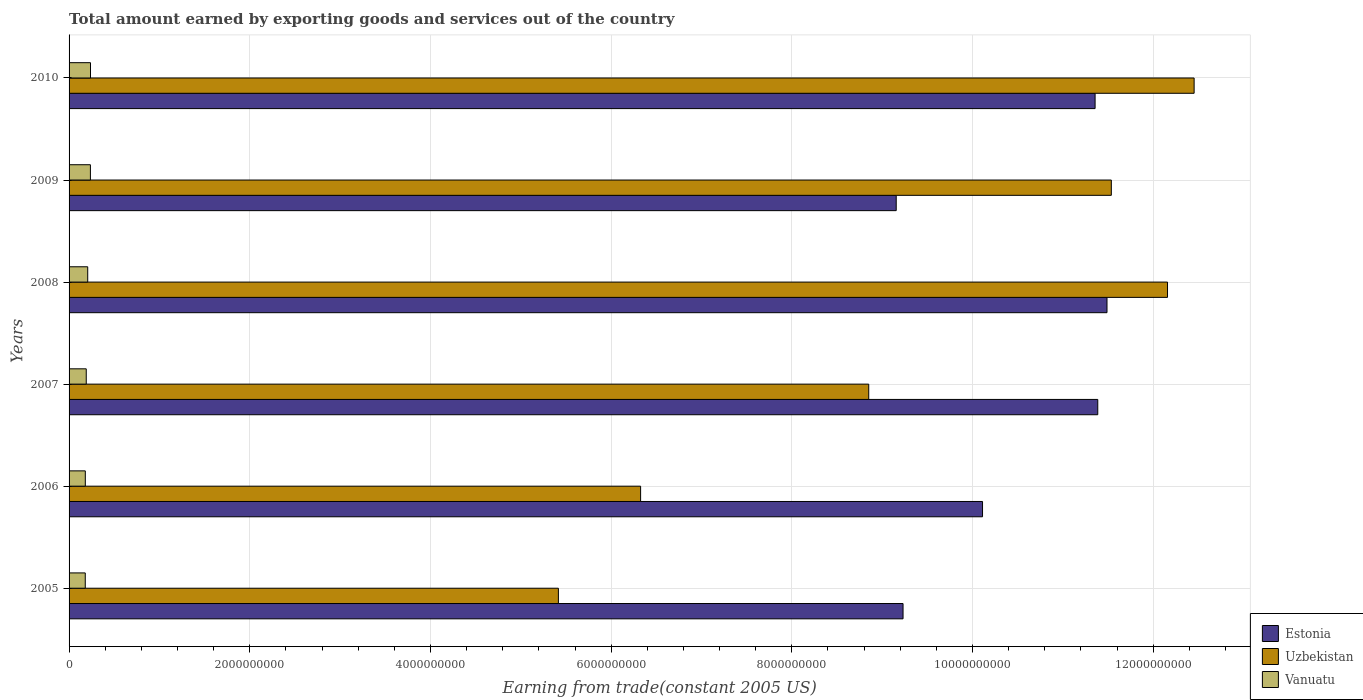How many different coloured bars are there?
Offer a very short reply. 3. How many bars are there on the 3rd tick from the top?
Your answer should be very brief. 3. In how many cases, is the number of bars for a given year not equal to the number of legend labels?
Give a very brief answer. 0. What is the total amount earned by exporting goods and services in Uzbekistan in 2006?
Keep it short and to the point. 6.33e+09. Across all years, what is the maximum total amount earned by exporting goods and services in Uzbekistan?
Provide a short and direct response. 1.25e+1. Across all years, what is the minimum total amount earned by exporting goods and services in Vanuatu?
Make the answer very short. 1.79e+08. In which year was the total amount earned by exporting goods and services in Estonia minimum?
Give a very brief answer. 2009. What is the total total amount earned by exporting goods and services in Estonia in the graph?
Keep it short and to the point. 6.27e+1. What is the difference between the total amount earned by exporting goods and services in Estonia in 2006 and that in 2009?
Make the answer very short. 9.55e+08. What is the difference between the total amount earned by exporting goods and services in Estonia in 2006 and the total amount earned by exporting goods and services in Uzbekistan in 2005?
Make the answer very short. 4.69e+09. What is the average total amount earned by exporting goods and services in Uzbekistan per year?
Ensure brevity in your answer.  9.46e+09. In the year 2009, what is the difference between the total amount earned by exporting goods and services in Estonia and total amount earned by exporting goods and services in Uzbekistan?
Your answer should be very brief. -2.38e+09. In how many years, is the total amount earned by exporting goods and services in Uzbekistan greater than 10000000000 US$?
Your answer should be compact. 3. What is the ratio of the total amount earned by exporting goods and services in Uzbekistan in 2006 to that in 2010?
Offer a terse response. 0.51. What is the difference between the highest and the second highest total amount earned by exporting goods and services in Estonia?
Provide a succinct answer. 1.02e+08. What is the difference between the highest and the lowest total amount earned by exporting goods and services in Uzbekistan?
Your answer should be compact. 7.04e+09. In how many years, is the total amount earned by exporting goods and services in Uzbekistan greater than the average total amount earned by exporting goods and services in Uzbekistan taken over all years?
Provide a succinct answer. 3. What does the 2nd bar from the top in 2009 represents?
Keep it short and to the point. Uzbekistan. What does the 3rd bar from the bottom in 2009 represents?
Make the answer very short. Vanuatu. Is it the case that in every year, the sum of the total amount earned by exporting goods and services in Vanuatu and total amount earned by exporting goods and services in Uzbekistan is greater than the total amount earned by exporting goods and services in Estonia?
Make the answer very short. No. How many bars are there?
Your response must be concise. 18. How many years are there in the graph?
Offer a very short reply. 6. Are the values on the major ticks of X-axis written in scientific E-notation?
Provide a short and direct response. No. Does the graph contain any zero values?
Make the answer very short. No. Where does the legend appear in the graph?
Your answer should be very brief. Bottom right. How many legend labels are there?
Provide a short and direct response. 3. How are the legend labels stacked?
Offer a terse response. Vertical. What is the title of the graph?
Give a very brief answer. Total amount earned by exporting goods and services out of the country. What is the label or title of the X-axis?
Your answer should be compact. Earning from trade(constant 2005 US). What is the label or title of the Y-axis?
Ensure brevity in your answer.  Years. What is the Earning from trade(constant 2005 US) of Estonia in 2005?
Offer a terse response. 9.23e+09. What is the Earning from trade(constant 2005 US) of Uzbekistan in 2005?
Your response must be concise. 5.42e+09. What is the Earning from trade(constant 2005 US) in Vanuatu in 2005?
Your response must be concise. 1.79e+08. What is the Earning from trade(constant 2005 US) of Estonia in 2006?
Make the answer very short. 1.01e+1. What is the Earning from trade(constant 2005 US) of Uzbekistan in 2006?
Keep it short and to the point. 6.33e+09. What is the Earning from trade(constant 2005 US) of Vanuatu in 2006?
Keep it short and to the point. 1.80e+08. What is the Earning from trade(constant 2005 US) of Estonia in 2007?
Make the answer very short. 1.14e+1. What is the Earning from trade(constant 2005 US) in Uzbekistan in 2007?
Keep it short and to the point. 8.85e+09. What is the Earning from trade(constant 2005 US) in Vanuatu in 2007?
Your response must be concise. 1.90e+08. What is the Earning from trade(constant 2005 US) in Estonia in 2008?
Your answer should be compact. 1.15e+1. What is the Earning from trade(constant 2005 US) of Uzbekistan in 2008?
Ensure brevity in your answer.  1.22e+1. What is the Earning from trade(constant 2005 US) of Vanuatu in 2008?
Keep it short and to the point. 2.06e+08. What is the Earning from trade(constant 2005 US) in Estonia in 2009?
Offer a terse response. 9.16e+09. What is the Earning from trade(constant 2005 US) of Uzbekistan in 2009?
Give a very brief answer. 1.15e+1. What is the Earning from trade(constant 2005 US) of Vanuatu in 2009?
Provide a short and direct response. 2.36e+08. What is the Earning from trade(constant 2005 US) in Estonia in 2010?
Your answer should be compact. 1.14e+1. What is the Earning from trade(constant 2005 US) in Uzbekistan in 2010?
Keep it short and to the point. 1.25e+1. What is the Earning from trade(constant 2005 US) in Vanuatu in 2010?
Offer a terse response. 2.37e+08. Across all years, what is the maximum Earning from trade(constant 2005 US) of Estonia?
Your response must be concise. 1.15e+1. Across all years, what is the maximum Earning from trade(constant 2005 US) in Uzbekistan?
Offer a very short reply. 1.25e+1. Across all years, what is the maximum Earning from trade(constant 2005 US) in Vanuatu?
Your response must be concise. 2.37e+08. Across all years, what is the minimum Earning from trade(constant 2005 US) of Estonia?
Your answer should be very brief. 9.16e+09. Across all years, what is the minimum Earning from trade(constant 2005 US) of Uzbekistan?
Make the answer very short. 5.42e+09. Across all years, what is the minimum Earning from trade(constant 2005 US) of Vanuatu?
Your answer should be very brief. 1.79e+08. What is the total Earning from trade(constant 2005 US) in Estonia in the graph?
Keep it short and to the point. 6.27e+1. What is the total Earning from trade(constant 2005 US) in Uzbekistan in the graph?
Provide a succinct answer. 5.67e+1. What is the total Earning from trade(constant 2005 US) in Vanuatu in the graph?
Make the answer very short. 1.23e+09. What is the difference between the Earning from trade(constant 2005 US) in Estonia in 2005 and that in 2006?
Provide a succinct answer. -8.80e+08. What is the difference between the Earning from trade(constant 2005 US) in Uzbekistan in 2005 and that in 2006?
Provide a short and direct response. -9.10e+08. What is the difference between the Earning from trade(constant 2005 US) of Vanuatu in 2005 and that in 2006?
Provide a short and direct response. -4.48e+05. What is the difference between the Earning from trade(constant 2005 US) in Estonia in 2005 and that in 2007?
Keep it short and to the point. -2.16e+09. What is the difference between the Earning from trade(constant 2005 US) in Uzbekistan in 2005 and that in 2007?
Provide a short and direct response. -3.44e+09. What is the difference between the Earning from trade(constant 2005 US) of Vanuatu in 2005 and that in 2007?
Provide a short and direct response. -1.09e+07. What is the difference between the Earning from trade(constant 2005 US) of Estonia in 2005 and that in 2008?
Your answer should be very brief. -2.26e+09. What is the difference between the Earning from trade(constant 2005 US) of Uzbekistan in 2005 and that in 2008?
Keep it short and to the point. -6.74e+09. What is the difference between the Earning from trade(constant 2005 US) of Vanuatu in 2005 and that in 2008?
Offer a very short reply. -2.72e+07. What is the difference between the Earning from trade(constant 2005 US) of Estonia in 2005 and that in 2009?
Your answer should be very brief. 7.57e+07. What is the difference between the Earning from trade(constant 2005 US) in Uzbekistan in 2005 and that in 2009?
Offer a very short reply. -6.12e+09. What is the difference between the Earning from trade(constant 2005 US) in Vanuatu in 2005 and that in 2009?
Ensure brevity in your answer.  -5.70e+07. What is the difference between the Earning from trade(constant 2005 US) of Estonia in 2005 and that in 2010?
Your answer should be very brief. -2.13e+09. What is the difference between the Earning from trade(constant 2005 US) of Uzbekistan in 2005 and that in 2010?
Give a very brief answer. -7.04e+09. What is the difference between the Earning from trade(constant 2005 US) of Vanuatu in 2005 and that in 2010?
Make the answer very short. -5.80e+07. What is the difference between the Earning from trade(constant 2005 US) of Estonia in 2006 and that in 2007?
Provide a short and direct response. -1.28e+09. What is the difference between the Earning from trade(constant 2005 US) of Uzbekistan in 2006 and that in 2007?
Your response must be concise. -2.52e+09. What is the difference between the Earning from trade(constant 2005 US) of Vanuatu in 2006 and that in 2007?
Give a very brief answer. -1.04e+07. What is the difference between the Earning from trade(constant 2005 US) in Estonia in 2006 and that in 2008?
Your response must be concise. -1.38e+09. What is the difference between the Earning from trade(constant 2005 US) of Uzbekistan in 2006 and that in 2008?
Ensure brevity in your answer.  -5.83e+09. What is the difference between the Earning from trade(constant 2005 US) in Vanuatu in 2006 and that in 2008?
Ensure brevity in your answer.  -2.68e+07. What is the difference between the Earning from trade(constant 2005 US) of Estonia in 2006 and that in 2009?
Your answer should be compact. 9.55e+08. What is the difference between the Earning from trade(constant 2005 US) in Uzbekistan in 2006 and that in 2009?
Provide a short and direct response. -5.21e+09. What is the difference between the Earning from trade(constant 2005 US) in Vanuatu in 2006 and that in 2009?
Your answer should be compact. -5.65e+07. What is the difference between the Earning from trade(constant 2005 US) in Estonia in 2006 and that in 2010?
Provide a succinct answer. -1.25e+09. What is the difference between the Earning from trade(constant 2005 US) in Uzbekistan in 2006 and that in 2010?
Make the answer very short. -6.13e+09. What is the difference between the Earning from trade(constant 2005 US) in Vanuatu in 2006 and that in 2010?
Offer a very short reply. -5.75e+07. What is the difference between the Earning from trade(constant 2005 US) of Estonia in 2007 and that in 2008?
Offer a very short reply. -1.02e+08. What is the difference between the Earning from trade(constant 2005 US) in Uzbekistan in 2007 and that in 2008?
Your response must be concise. -3.31e+09. What is the difference between the Earning from trade(constant 2005 US) of Vanuatu in 2007 and that in 2008?
Provide a succinct answer. -1.64e+07. What is the difference between the Earning from trade(constant 2005 US) of Estonia in 2007 and that in 2009?
Offer a terse response. 2.23e+09. What is the difference between the Earning from trade(constant 2005 US) in Uzbekistan in 2007 and that in 2009?
Ensure brevity in your answer.  -2.69e+09. What is the difference between the Earning from trade(constant 2005 US) in Vanuatu in 2007 and that in 2009?
Offer a terse response. -4.61e+07. What is the difference between the Earning from trade(constant 2005 US) of Estonia in 2007 and that in 2010?
Offer a very short reply. 2.95e+07. What is the difference between the Earning from trade(constant 2005 US) of Uzbekistan in 2007 and that in 2010?
Your response must be concise. -3.60e+09. What is the difference between the Earning from trade(constant 2005 US) in Vanuatu in 2007 and that in 2010?
Keep it short and to the point. -4.71e+07. What is the difference between the Earning from trade(constant 2005 US) in Estonia in 2008 and that in 2009?
Make the answer very short. 2.33e+09. What is the difference between the Earning from trade(constant 2005 US) of Uzbekistan in 2008 and that in 2009?
Offer a very short reply. 6.22e+08. What is the difference between the Earning from trade(constant 2005 US) of Vanuatu in 2008 and that in 2009?
Give a very brief answer. -2.98e+07. What is the difference between the Earning from trade(constant 2005 US) of Estonia in 2008 and that in 2010?
Make the answer very short. 1.32e+08. What is the difference between the Earning from trade(constant 2005 US) in Uzbekistan in 2008 and that in 2010?
Your response must be concise. -2.95e+08. What is the difference between the Earning from trade(constant 2005 US) in Vanuatu in 2008 and that in 2010?
Your answer should be compact. -3.07e+07. What is the difference between the Earning from trade(constant 2005 US) in Estonia in 2009 and that in 2010?
Provide a succinct answer. -2.20e+09. What is the difference between the Earning from trade(constant 2005 US) of Uzbekistan in 2009 and that in 2010?
Offer a terse response. -9.17e+08. What is the difference between the Earning from trade(constant 2005 US) in Vanuatu in 2009 and that in 2010?
Your answer should be compact. -9.76e+05. What is the difference between the Earning from trade(constant 2005 US) of Estonia in 2005 and the Earning from trade(constant 2005 US) of Uzbekistan in 2006?
Provide a succinct answer. 2.90e+09. What is the difference between the Earning from trade(constant 2005 US) in Estonia in 2005 and the Earning from trade(constant 2005 US) in Vanuatu in 2006?
Ensure brevity in your answer.  9.05e+09. What is the difference between the Earning from trade(constant 2005 US) in Uzbekistan in 2005 and the Earning from trade(constant 2005 US) in Vanuatu in 2006?
Your answer should be compact. 5.24e+09. What is the difference between the Earning from trade(constant 2005 US) of Estonia in 2005 and the Earning from trade(constant 2005 US) of Uzbekistan in 2007?
Give a very brief answer. 3.80e+08. What is the difference between the Earning from trade(constant 2005 US) in Estonia in 2005 and the Earning from trade(constant 2005 US) in Vanuatu in 2007?
Ensure brevity in your answer.  9.04e+09. What is the difference between the Earning from trade(constant 2005 US) of Uzbekistan in 2005 and the Earning from trade(constant 2005 US) of Vanuatu in 2007?
Your answer should be very brief. 5.23e+09. What is the difference between the Earning from trade(constant 2005 US) in Estonia in 2005 and the Earning from trade(constant 2005 US) in Uzbekistan in 2008?
Offer a very short reply. -2.93e+09. What is the difference between the Earning from trade(constant 2005 US) in Estonia in 2005 and the Earning from trade(constant 2005 US) in Vanuatu in 2008?
Offer a terse response. 9.02e+09. What is the difference between the Earning from trade(constant 2005 US) in Uzbekistan in 2005 and the Earning from trade(constant 2005 US) in Vanuatu in 2008?
Your response must be concise. 5.21e+09. What is the difference between the Earning from trade(constant 2005 US) of Estonia in 2005 and the Earning from trade(constant 2005 US) of Uzbekistan in 2009?
Your answer should be compact. -2.31e+09. What is the difference between the Earning from trade(constant 2005 US) of Estonia in 2005 and the Earning from trade(constant 2005 US) of Vanuatu in 2009?
Provide a succinct answer. 8.99e+09. What is the difference between the Earning from trade(constant 2005 US) in Uzbekistan in 2005 and the Earning from trade(constant 2005 US) in Vanuatu in 2009?
Offer a very short reply. 5.18e+09. What is the difference between the Earning from trade(constant 2005 US) of Estonia in 2005 and the Earning from trade(constant 2005 US) of Uzbekistan in 2010?
Provide a short and direct response. -3.22e+09. What is the difference between the Earning from trade(constant 2005 US) in Estonia in 2005 and the Earning from trade(constant 2005 US) in Vanuatu in 2010?
Give a very brief answer. 8.99e+09. What is the difference between the Earning from trade(constant 2005 US) in Uzbekistan in 2005 and the Earning from trade(constant 2005 US) in Vanuatu in 2010?
Your response must be concise. 5.18e+09. What is the difference between the Earning from trade(constant 2005 US) of Estonia in 2006 and the Earning from trade(constant 2005 US) of Uzbekistan in 2007?
Offer a terse response. 1.26e+09. What is the difference between the Earning from trade(constant 2005 US) of Estonia in 2006 and the Earning from trade(constant 2005 US) of Vanuatu in 2007?
Give a very brief answer. 9.92e+09. What is the difference between the Earning from trade(constant 2005 US) of Uzbekistan in 2006 and the Earning from trade(constant 2005 US) of Vanuatu in 2007?
Offer a terse response. 6.14e+09. What is the difference between the Earning from trade(constant 2005 US) in Estonia in 2006 and the Earning from trade(constant 2005 US) in Uzbekistan in 2008?
Make the answer very short. -2.05e+09. What is the difference between the Earning from trade(constant 2005 US) in Estonia in 2006 and the Earning from trade(constant 2005 US) in Vanuatu in 2008?
Make the answer very short. 9.90e+09. What is the difference between the Earning from trade(constant 2005 US) of Uzbekistan in 2006 and the Earning from trade(constant 2005 US) of Vanuatu in 2008?
Offer a very short reply. 6.12e+09. What is the difference between the Earning from trade(constant 2005 US) of Estonia in 2006 and the Earning from trade(constant 2005 US) of Uzbekistan in 2009?
Offer a terse response. -1.43e+09. What is the difference between the Earning from trade(constant 2005 US) in Estonia in 2006 and the Earning from trade(constant 2005 US) in Vanuatu in 2009?
Provide a succinct answer. 9.87e+09. What is the difference between the Earning from trade(constant 2005 US) in Uzbekistan in 2006 and the Earning from trade(constant 2005 US) in Vanuatu in 2009?
Provide a succinct answer. 6.09e+09. What is the difference between the Earning from trade(constant 2005 US) in Estonia in 2006 and the Earning from trade(constant 2005 US) in Uzbekistan in 2010?
Your response must be concise. -2.34e+09. What is the difference between the Earning from trade(constant 2005 US) of Estonia in 2006 and the Earning from trade(constant 2005 US) of Vanuatu in 2010?
Make the answer very short. 9.87e+09. What is the difference between the Earning from trade(constant 2005 US) of Uzbekistan in 2006 and the Earning from trade(constant 2005 US) of Vanuatu in 2010?
Your answer should be compact. 6.09e+09. What is the difference between the Earning from trade(constant 2005 US) in Estonia in 2007 and the Earning from trade(constant 2005 US) in Uzbekistan in 2008?
Give a very brief answer. -7.72e+08. What is the difference between the Earning from trade(constant 2005 US) of Estonia in 2007 and the Earning from trade(constant 2005 US) of Vanuatu in 2008?
Your answer should be compact. 1.12e+1. What is the difference between the Earning from trade(constant 2005 US) of Uzbekistan in 2007 and the Earning from trade(constant 2005 US) of Vanuatu in 2008?
Your answer should be compact. 8.64e+09. What is the difference between the Earning from trade(constant 2005 US) in Estonia in 2007 and the Earning from trade(constant 2005 US) in Uzbekistan in 2009?
Your answer should be compact. -1.50e+08. What is the difference between the Earning from trade(constant 2005 US) in Estonia in 2007 and the Earning from trade(constant 2005 US) in Vanuatu in 2009?
Make the answer very short. 1.11e+1. What is the difference between the Earning from trade(constant 2005 US) in Uzbekistan in 2007 and the Earning from trade(constant 2005 US) in Vanuatu in 2009?
Your answer should be compact. 8.61e+09. What is the difference between the Earning from trade(constant 2005 US) of Estonia in 2007 and the Earning from trade(constant 2005 US) of Uzbekistan in 2010?
Your answer should be compact. -1.07e+09. What is the difference between the Earning from trade(constant 2005 US) in Estonia in 2007 and the Earning from trade(constant 2005 US) in Vanuatu in 2010?
Your response must be concise. 1.11e+1. What is the difference between the Earning from trade(constant 2005 US) in Uzbekistan in 2007 and the Earning from trade(constant 2005 US) in Vanuatu in 2010?
Provide a short and direct response. 8.61e+09. What is the difference between the Earning from trade(constant 2005 US) of Estonia in 2008 and the Earning from trade(constant 2005 US) of Uzbekistan in 2009?
Offer a terse response. -4.79e+07. What is the difference between the Earning from trade(constant 2005 US) of Estonia in 2008 and the Earning from trade(constant 2005 US) of Vanuatu in 2009?
Ensure brevity in your answer.  1.13e+1. What is the difference between the Earning from trade(constant 2005 US) in Uzbekistan in 2008 and the Earning from trade(constant 2005 US) in Vanuatu in 2009?
Make the answer very short. 1.19e+1. What is the difference between the Earning from trade(constant 2005 US) of Estonia in 2008 and the Earning from trade(constant 2005 US) of Uzbekistan in 2010?
Offer a very short reply. -9.64e+08. What is the difference between the Earning from trade(constant 2005 US) in Estonia in 2008 and the Earning from trade(constant 2005 US) in Vanuatu in 2010?
Provide a succinct answer. 1.13e+1. What is the difference between the Earning from trade(constant 2005 US) in Uzbekistan in 2008 and the Earning from trade(constant 2005 US) in Vanuatu in 2010?
Provide a short and direct response. 1.19e+1. What is the difference between the Earning from trade(constant 2005 US) of Estonia in 2009 and the Earning from trade(constant 2005 US) of Uzbekistan in 2010?
Provide a succinct answer. -3.30e+09. What is the difference between the Earning from trade(constant 2005 US) in Estonia in 2009 and the Earning from trade(constant 2005 US) in Vanuatu in 2010?
Keep it short and to the point. 8.92e+09. What is the difference between the Earning from trade(constant 2005 US) of Uzbekistan in 2009 and the Earning from trade(constant 2005 US) of Vanuatu in 2010?
Your answer should be very brief. 1.13e+1. What is the average Earning from trade(constant 2005 US) of Estonia per year?
Offer a terse response. 1.05e+1. What is the average Earning from trade(constant 2005 US) of Uzbekistan per year?
Provide a short and direct response. 9.46e+09. What is the average Earning from trade(constant 2005 US) in Vanuatu per year?
Ensure brevity in your answer.  2.05e+08. In the year 2005, what is the difference between the Earning from trade(constant 2005 US) in Estonia and Earning from trade(constant 2005 US) in Uzbekistan?
Provide a succinct answer. 3.81e+09. In the year 2005, what is the difference between the Earning from trade(constant 2005 US) in Estonia and Earning from trade(constant 2005 US) in Vanuatu?
Keep it short and to the point. 9.05e+09. In the year 2005, what is the difference between the Earning from trade(constant 2005 US) of Uzbekistan and Earning from trade(constant 2005 US) of Vanuatu?
Give a very brief answer. 5.24e+09. In the year 2006, what is the difference between the Earning from trade(constant 2005 US) of Estonia and Earning from trade(constant 2005 US) of Uzbekistan?
Provide a succinct answer. 3.78e+09. In the year 2006, what is the difference between the Earning from trade(constant 2005 US) of Estonia and Earning from trade(constant 2005 US) of Vanuatu?
Your response must be concise. 9.93e+09. In the year 2006, what is the difference between the Earning from trade(constant 2005 US) of Uzbekistan and Earning from trade(constant 2005 US) of Vanuatu?
Offer a terse response. 6.15e+09. In the year 2007, what is the difference between the Earning from trade(constant 2005 US) in Estonia and Earning from trade(constant 2005 US) in Uzbekistan?
Make the answer very short. 2.53e+09. In the year 2007, what is the difference between the Earning from trade(constant 2005 US) of Estonia and Earning from trade(constant 2005 US) of Vanuatu?
Your response must be concise. 1.12e+1. In the year 2007, what is the difference between the Earning from trade(constant 2005 US) of Uzbekistan and Earning from trade(constant 2005 US) of Vanuatu?
Your answer should be compact. 8.66e+09. In the year 2008, what is the difference between the Earning from trade(constant 2005 US) of Estonia and Earning from trade(constant 2005 US) of Uzbekistan?
Give a very brief answer. -6.70e+08. In the year 2008, what is the difference between the Earning from trade(constant 2005 US) in Estonia and Earning from trade(constant 2005 US) in Vanuatu?
Make the answer very short. 1.13e+1. In the year 2008, what is the difference between the Earning from trade(constant 2005 US) of Uzbekistan and Earning from trade(constant 2005 US) of Vanuatu?
Your answer should be very brief. 1.20e+1. In the year 2009, what is the difference between the Earning from trade(constant 2005 US) in Estonia and Earning from trade(constant 2005 US) in Uzbekistan?
Give a very brief answer. -2.38e+09. In the year 2009, what is the difference between the Earning from trade(constant 2005 US) in Estonia and Earning from trade(constant 2005 US) in Vanuatu?
Your answer should be very brief. 8.92e+09. In the year 2009, what is the difference between the Earning from trade(constant 2005 US) of Uzbekistan and Earning from trade(constant 2005 US) of Vanuatu?
Offer a terse response. 1.13e+1. In the year 2010, what is the difference between the Earning from trade(constant 2005 US) of Estonia and Earning from trade(constant 2005 US) of Uzbekistan?
Make the answer very short. -1.10e+09. In the year 2010, what is the difference between the Earning from trade(constant 2005 US) in Estonia and Earning from trade(constant 2005 US) in Vanuatu?
Your answer should be very brief. 1.11e+1. In the year 2010, what is the difference between the Earning from trade(constant 2005 US) in Uzbekistan and Earning from trade(constant 2005 US) in Vanuatu?
Offer a very short reply. 1.22e+1. What is the ratio of the Earning from trade(constant 2005 US) of Uzbekistan in 2005 to that in 2006?
Provide a short and direct response. 0.86. What is the ratio of the Earning from trade(constant 2005 US) in Vanuatu in 2005 to that in 2006?
Make the answer very short. 1. What is the ratio of the Earning from trade(constant 2005 US) in Estonia in 2005 to that in 2007?
Provide a succinct answer. 0.81. What is the ratio of the Earning from trade(constant 2005 US) of Uzbekistan in 2005 to that in 2007?
Offer a terse response. 0.61. What is the ratio of the Earning from trade(constant 2005 US) of Vanuatu in 2005 to that in 2007?
Your answer should be very brief. 0.94. What is the ratio of the Earning from trade(constant 2005 US) of Estonia in 2005 to that in 2008?
Give a very brief answer. 0.8. What is the ratio of the Earning from trade(constant 2005 US) in Uzbekistan in 2005 to that in 2008?
Make the answer very short. 0.45. What is the ratio of the Earning from trade(constant 2005 US) in Vanuatu in 2005 to that in 2008?
Your answer should be very brief. 0.87. What is the ratio of the Earning from trade(constant 2005 US) of Estonia in 2005 to that in 2009?
Offer a terse response. 1.01. What is the ratio of the Earning from trade(constant 2005 US) of Uzbekistan in 2005 to that in 2009?
Give a very brief answer. 0.47. What is the ratio of the Earning from trade(constant 2005 US) of Vanuatu in 2005 to that in 2009?
Your answer should be compact. 0.76. What is the ratio of the Earning from trade(constant 2005 US) of Estonia in 2005 to that in 2010?
Your response must be concise. 0.81. What is the ratio of the Earning from trade(constant 2005 US) in Uzbekistan in 2005 to that in 2010?
Offer a very short reply. 0.43. What is the ratio of the Earning from trade(constant 2005 US) of Vanuatu in 2005 to that in 2010?
Your response must be concise. 0.76. What is the ratio of the Earning from trade(constant 2005 US) of Estonia in 2006 to that in 2007?
Your response must be concise. 0.89. What is the ratio of the Earning from trade(constant 2005 US) in Uzbekistan in 2006 to that in 2007?
Give a very brief answer. 0.71. What is the ratio of the Earning from trade(constant 2005 US) of Vanuatu in 2006 to that in 2007?
Keep it short and to the point. 0.95. What is the ratio of the Earning from trade(constant 2005 US) of Estonia in 2006 to that in 2008?
Give a very brief answer. 0.88. What is the ratio of the Earning from trade(constant 2005 US) in Uzbekistan in 2006 to that in 2008?
Offer a terse response. 0.52. What is the ratio of the Earning from trade(constant 2005 US) of Vanuatu in 2006 to that in 2008?
Provide a short and direct response. 0.87. What is the ratio of the Earning from trade(constant 2005 US) in Estonia in 2006 to that in 2009?
Your answer should be very brief. 1.1. What is the ratio of the Earning from trade(constant 2005 US) in Uzbekistan in 2006 to that in 2009?
Provide a short and direct response. 0.55. What is the ratio of the Earning from trade(constant 2005 US) of Vanuatu in 2006 to that in 2009?
Your answer should be compact. 0.76. What is the ratio of the Earning from trade(constant 2005 US) in Estonia in 2006 to that in 2010?
Offer a terse response. 0.89. What is the ratio of the Earning from trade(constant 2005 US) in Uzbekistan in 2006 to that in 2010?
Your answer should be very brief. 0.51. What is the ratio of the Earning from trade(constant 2005 US) in Vanuatu in 2006 to that in 2010?
Your response must be concise. 0.76. What is the ratio of the Earning from trade(constant 2005 US) in Estonia in 2007 to that in 2008?
Ensure brevity in your answer.  0.99. What is the ratio of the Earning from trade(constant 2005 US) in Uzbekistan in 2007 to that in 2008?
Ensure brevity in your answer.  0.73. What is the ratio of the Earning from trade(constant 2005 US) in Vanuatu in 2007 to that in 2008?
Provide a short and direct response. 0.92. What is the ratio of the Earning from trade(constant 2005 US) of Estonia in 2007 to that in 2009?
Your answer should be very brief. 1.24. What is the ratio of the Earning from trade(constant 2005 US) of Uzbekistan in 2007 to that in 2009?
Offer a terse response. 0.77. What is the ratio of the Earning from trade(constant 2005 US) in Vanuatu in 2007 to that in 2009?
Keep it short and to the point. 0.8. What is the ratio of the Earning from trade(constant 2005 US) of Estonia in 2007 to that in 2010?
Provide a succinct answer. 1. What is the ratio of the Earning from trade(constant 2005 US) in Uzbekistan in 2007 to that in 2010?
Keep it short and to the point. 0.71. What is the ratio of the Earning from trade(constant 2005 US) in Vanuatu in 2007 to that in 2010?
Provide a succinct answer. 0.8. What is the ratio of the Earning from trade(constant 2005 US) of Estonia in 2008 to that in 2009?
Give a very brief answer. 1.25. What is the ratio of the Earning from trade(constant 2005 US) in Uzbekistan in 2008 to that in 2009?
Your response must be concise. 1.05. What is the ratio of the Earning from trade(constant 2005 US) of Vanuatu in 2008 to that in 2009?
Your response must be concise. 0.87. What is the ratio of the Earning from trade(constant 2005 US) in Estonia in 2008 to that in 2010?
Keep it short and to the point. 1.01. What is the ratio of the Earning from trade(constant 2005 US) of Uzbekistan in 2008 to that in 2010?
Your answer should be very brief. 0.98. What is the ratio of the Earning from trade(constant 2005 US) in Vanuatu in 2008 to that in 2010?
Give a very brief answer. 0.87. What is the ratio of the Earning from trade(constant 2005 US) in Estonia in 2009 to that in 2010?
Provide a short and direct response. 0.81. What is the ratio of the Earning from trade(constant 2005 US) in Uzbekistan in 2009 to that in 2010?
Provide a short and direct response. 0.93. What is the ratio of the Earning from trade(constant 2005 US) in Vanuatu in 2009 to that in 2010?
Your answer should be compact. 1. What is the difference between the highest and the second highest Earning from trade(constant 2005 US) in Estonia?
Provide a succinct answer. 1.02e+08. What is the difference between the highest and the second highest Earning from trade(constant 2005 US) in Uzbekistan?
Keep it short and to the point. 2.95e+08. What is the difference between the highest and the second highest Earning from trade(constant 2005 US) in Vanuatu?
Give a very brief answer. 9.76e+05. What is the difference between the highest and the lowest Earning from trade(constant 2005 US) in Estonia?
Your answer should be compact. 2.33e+09. What is the difference between the highest and the lowest Earning from trade(constant 2005 US) in Uzbekistan?
Offer a terse response. 7.04e+09. What is the difference between the highest and the lowest Earning from trade(constant 2005 US) of Vanuatu?
Your answer should be compact. 5.80e+07. 